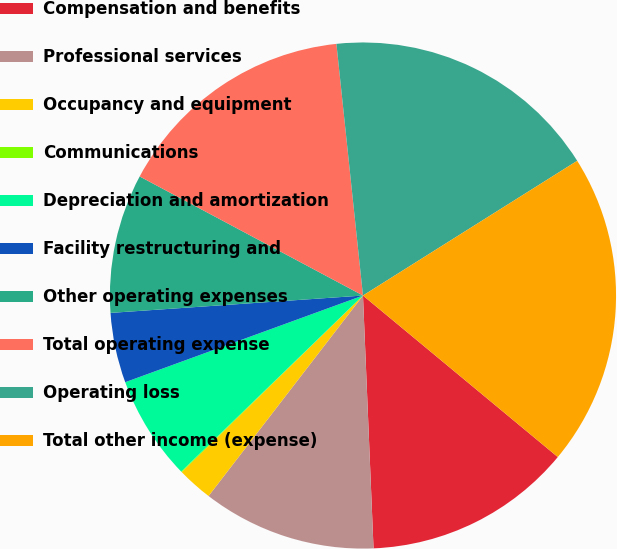Convert chart to OTSL. <chart><loc_0><loc_0><loc_500><loc_500><pie_chart><fcel>Compensation and benefits<fcel>Professional services<fcel>Occupancy and equipment<fcel>Communications<fcel>Depreciation and amortization<fcel>Facility restructuring and<fcel>Other operating expenses<fcel>Total operating expense<fcel>Operating loss<fcel>Total other income (expense)<nl><fcel>13.32%<fcel>11.11%<fcel>2.26%<fcel>0.05%<fcel>6.68%<fcel>4.47%<fcel>8.89%<fcel>15.53%<fcel>17.74%<fcel>19.95%<nl></chart> 